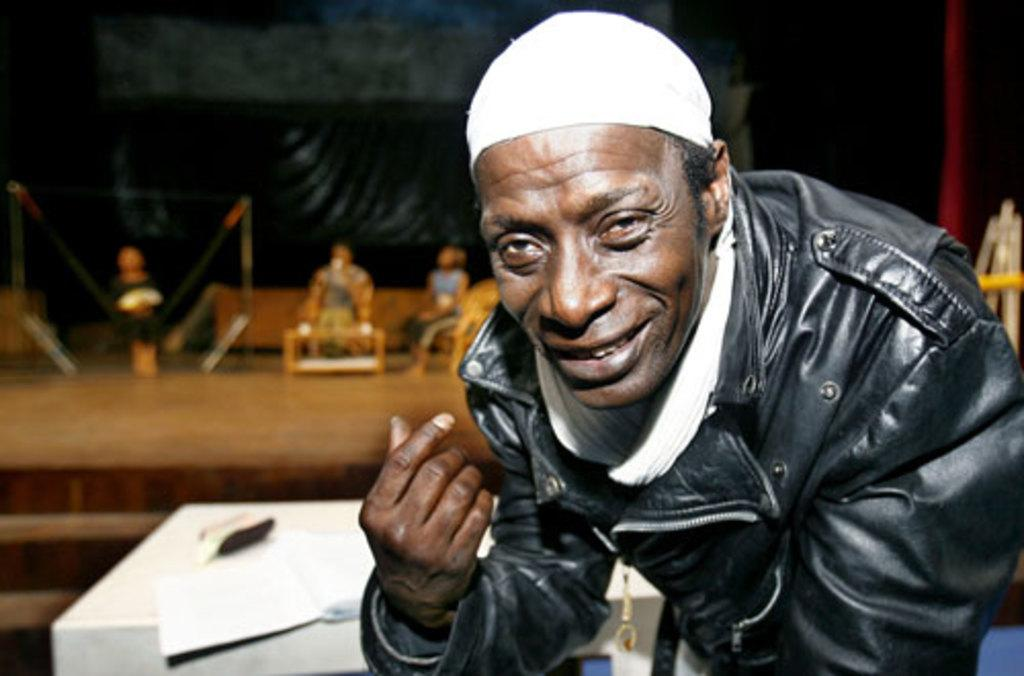What is the man in the image doing? The man is smiling in the image. What are the people in the image doing? The people are sitting in the image. What type of furniture is present in the image? There are chairs and tables in the image. What is the purpose of the drawing table in the image? The drawing table is likely used for drawing or sketching. What can be seen in the background of the image? There are objects visible in the background of the image. What type of feather can be seen on the island in the image? There is no island or feather present in the image. 